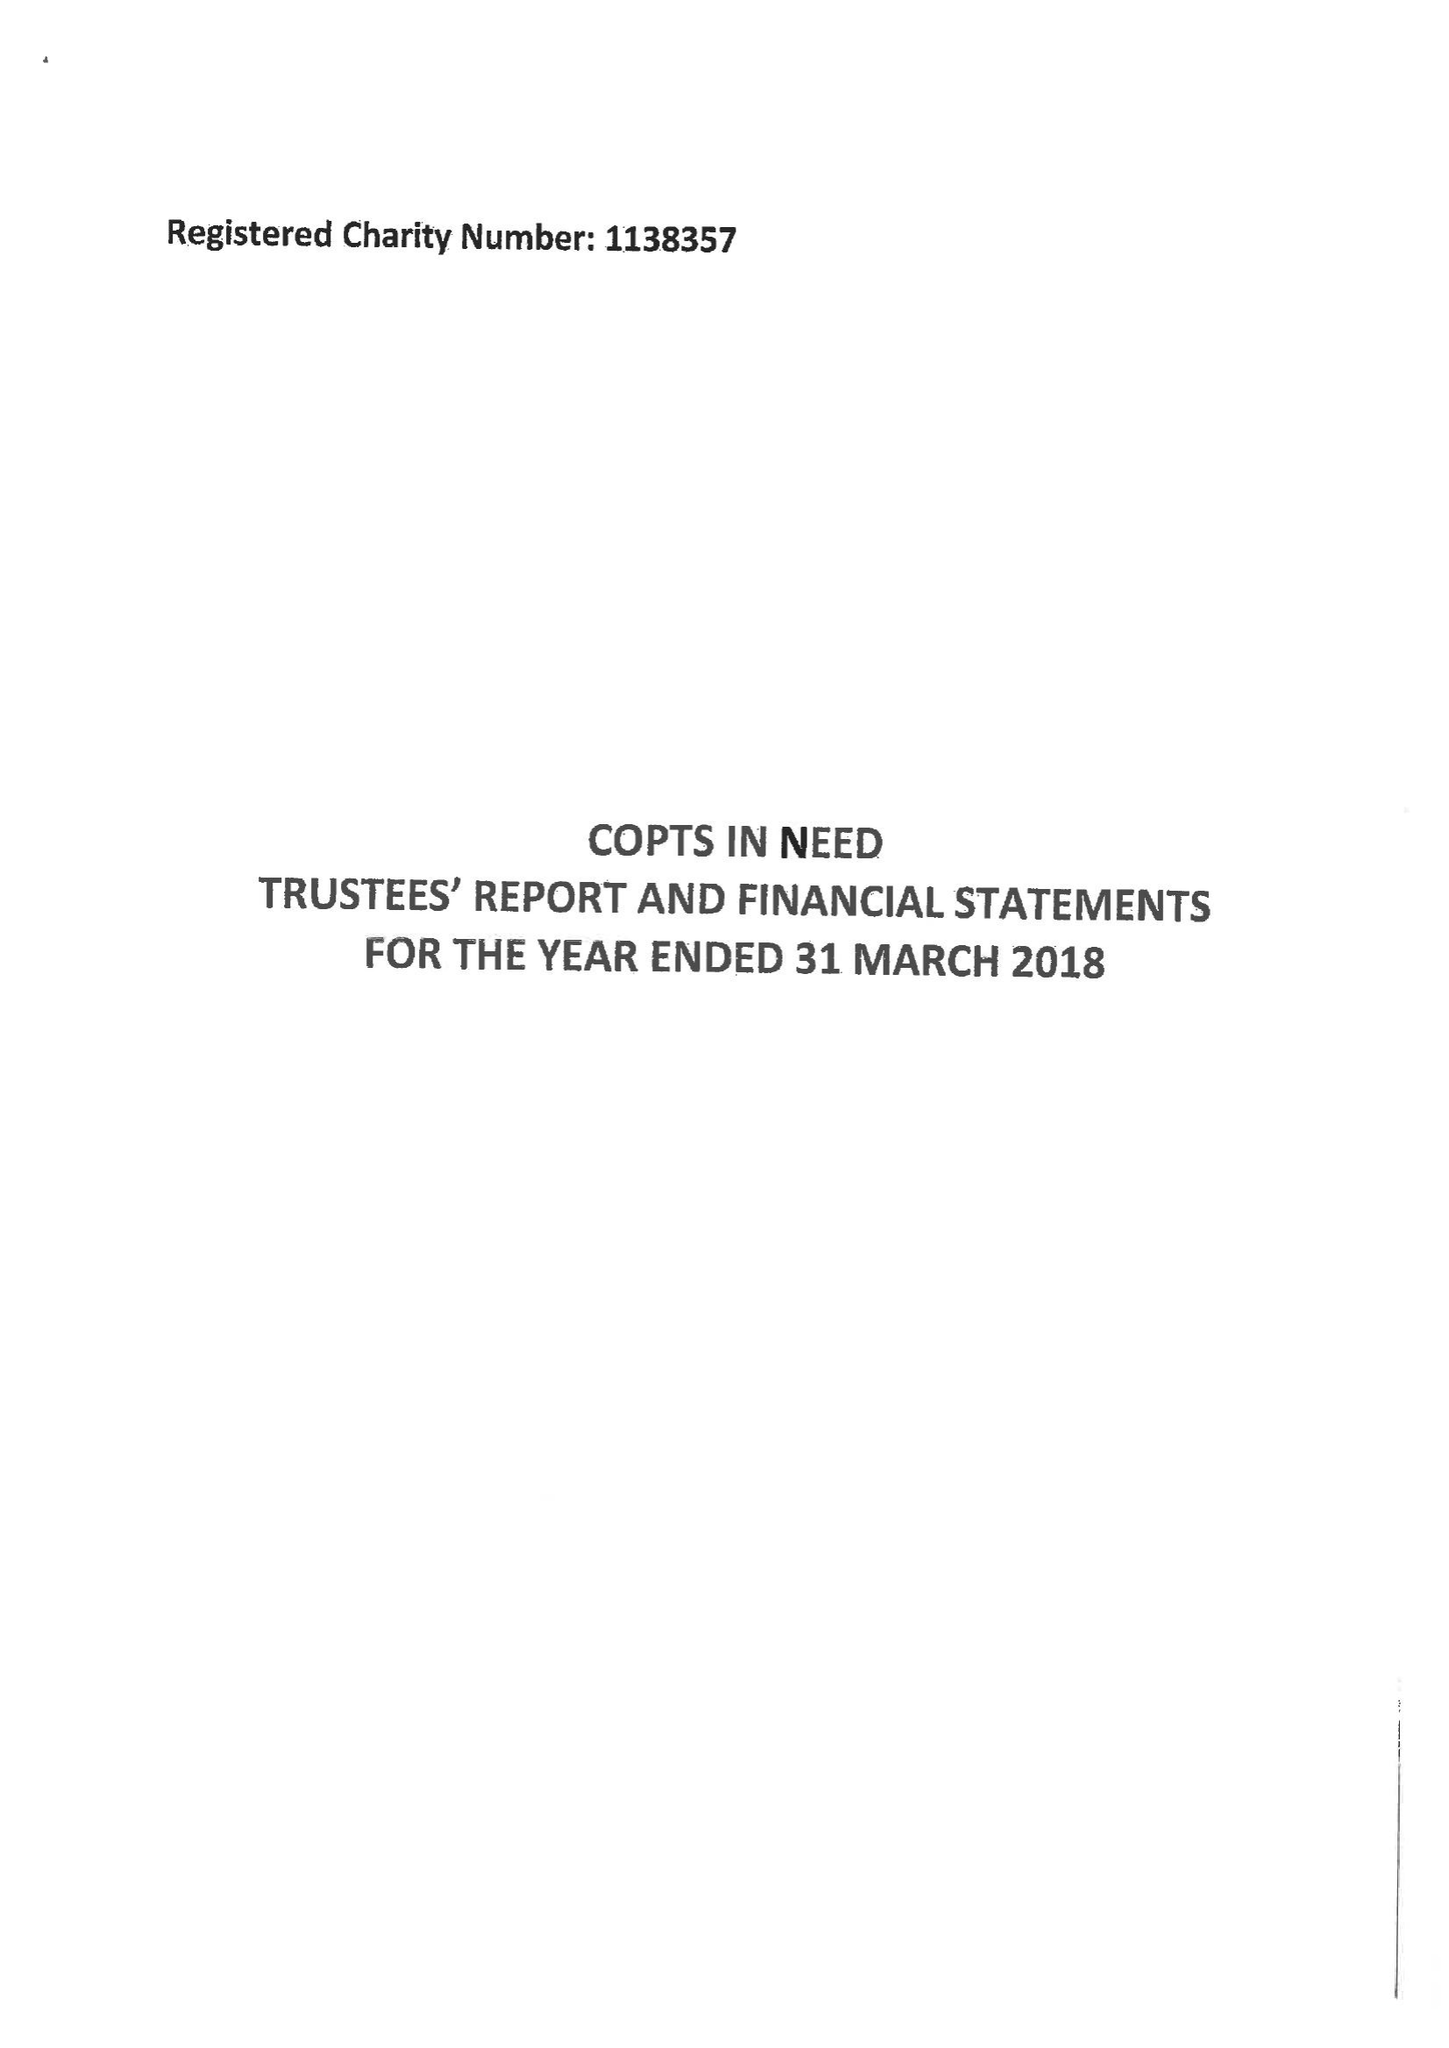What is the value for the income_annually_in_british_pounds?
Answer the question using a single word or phrase. 299841.00 